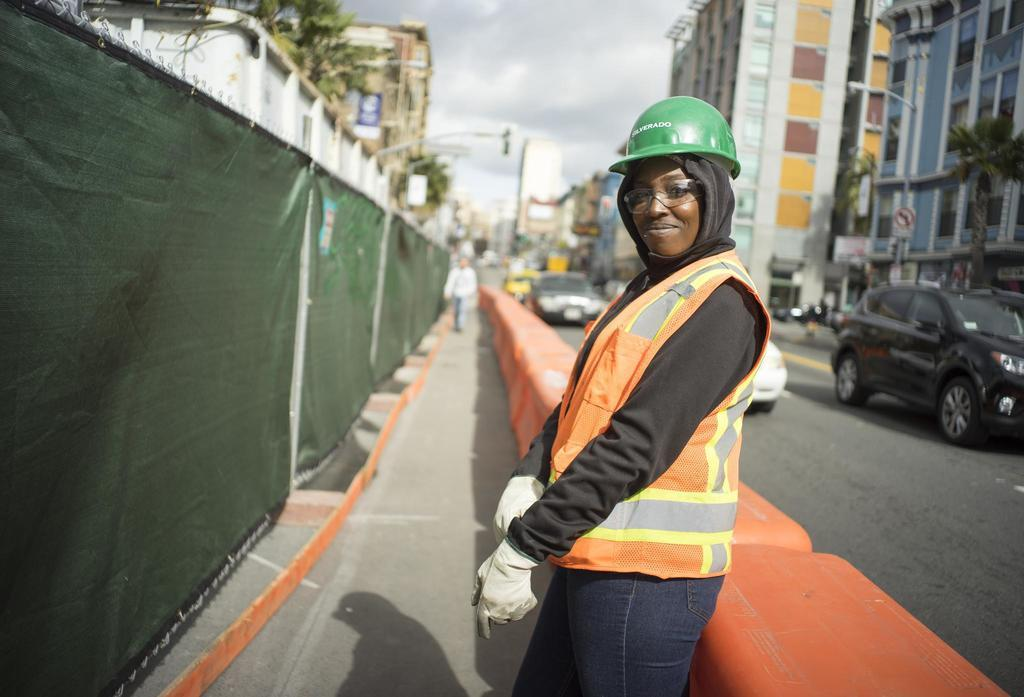How many people are present in the image? There are two persons standing in the image. What type of barriers can be seen in the image? There are jersey barricades in the image. What structures are visible in the image? There are buildings in the image. What type of vegetation is present in the image? There are trees in the image. What type of transportation is visible in the image? There are vehicles on the road in the image. What is visible in the background of the image? The sky is visible in the background of the image. Where is the faucet located in the image? There is no faucet present in the image. How many bridges can be seen crossing the road in the image? There are no bridges visible in the image; it only shows a road with vehicles and jersey barricades. 